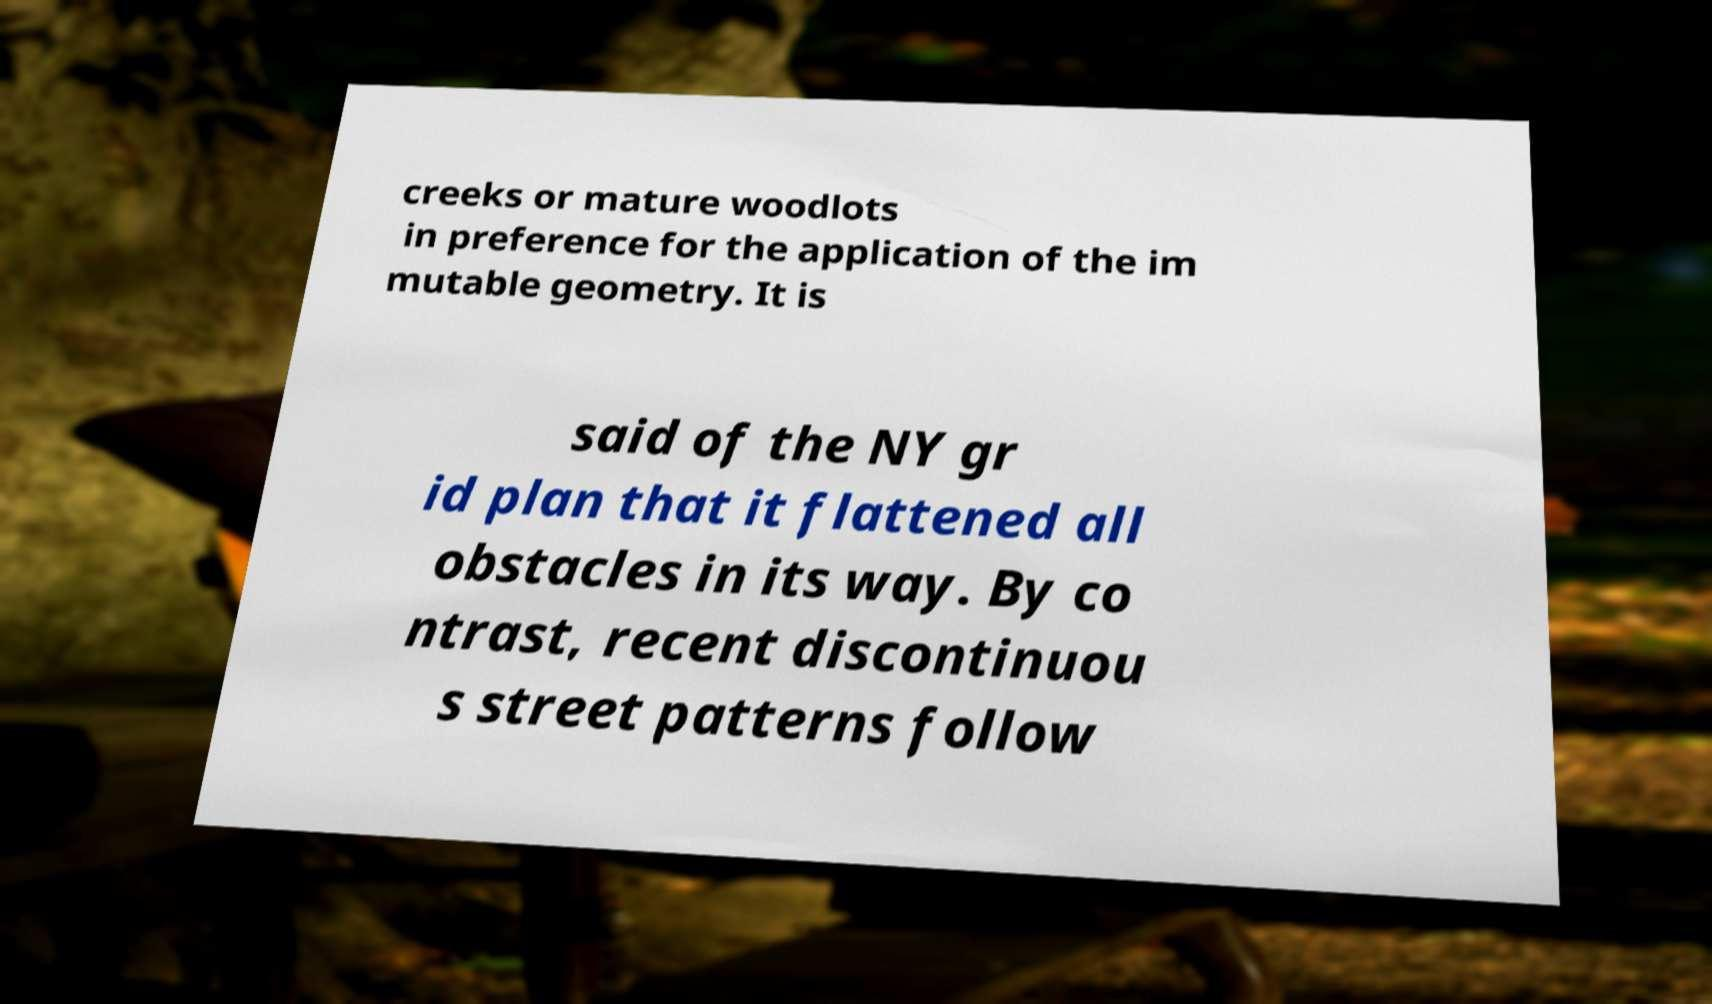Could you assist in decoding the text presented in this image and type it out clearly? creeks or mature woodlots in preference for the application of the im mutable geometry. It is said of the NY gr id plan that it flattened all obstacles in its way. By co ntrast, recent discontinuou s street patterns follow 